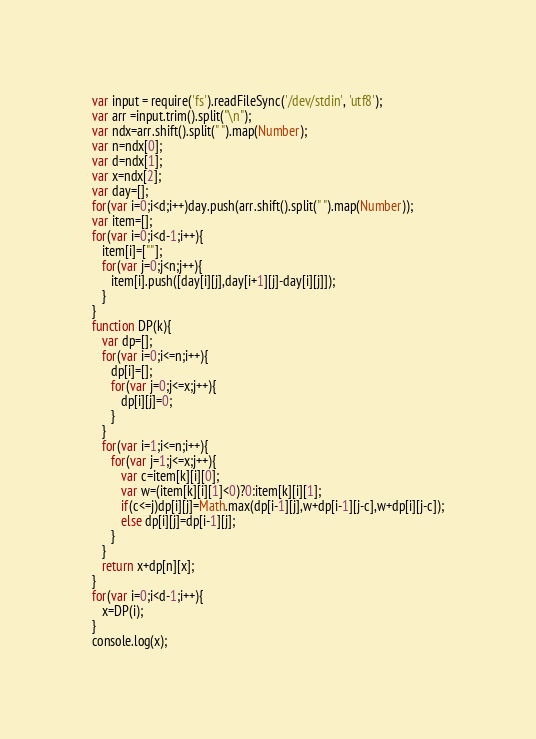Convert code to text. <code><loc_0><loc_0><loc_500><loc_500><_JavaScript_>var input = require('fs').readFileSync('/dev/stdin', 'utf8');
var arr =input.trim().split("\n");
var ndx=arr.shift().split(" ").map(Number);
var n=ndx[0];
var d=ndx[1];
var x=ndx[2];
var day=[];
for(var i=0;i<d;i++)day.push(arr.shift().split(" ").map(Number));
var item=[];
for(var i=0;i<d-1;i++){
   item[i]=[""];
   for(var j=0;j<n;j++){
      item[i].push([day[i][j],day[i+1][j]-day[i][j]]);
   }
}
function DP(k){
   var dp=[];
   for(var i=0;i<=n;i++){
      dp[i]=[];
      for(var j=0;j<=x;j++){
         dp[i][j]=0;
      }
   }
   for(var i=1;i<=n;i++){
      for(var j=1;j<=x;j++){
         var c=item[k][i][0];
         var w=(item[k][i][1]<0)?0:item[k][i][1];
         if(c<=j)dp[i][j]=Math.max(dp[i-1][j],w+dp[i-1][j-c],w+dp[i][j-c]);
         else dp[i][j]=dp[i-1][j];
      }
   }
   return x+dp[n][x];
}
for(var i=0;i<d-1;i++){
   x=DP(i);
}
console.log(x);</code> 